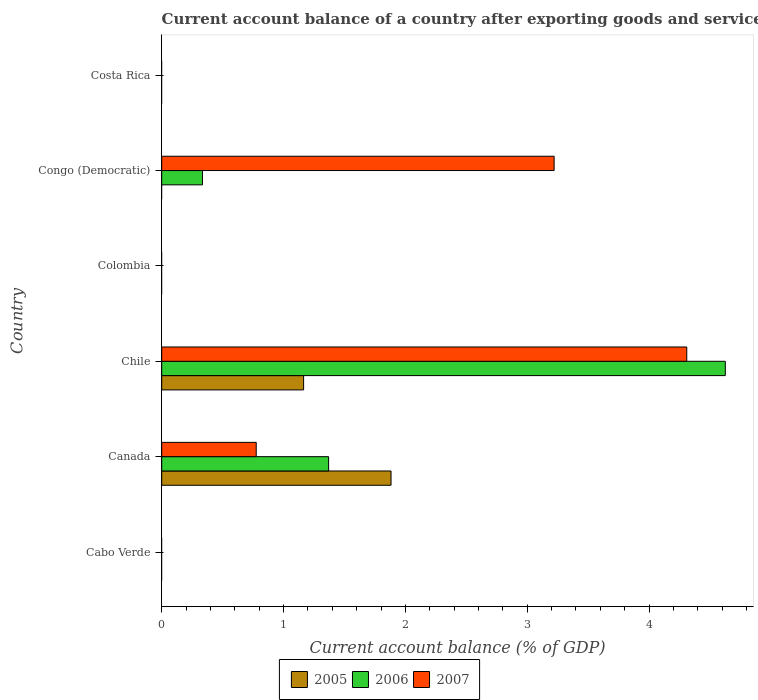How many different coloured bars are there?
Your answer should be very brief. 3. How many bars are there on the 6th tick from the bottom?
Ensure brevity in your answer.  0. What is the label of the 6th group of bars from the top?
Your response must be concise. Cabo Verde. What is the account balance in 2005 in Chile?
Give a very brief answer. 1.16. Across all countries, what is the maximum account balance in 2007?
Offer a terse response. 4.31. In which country was the account balance in 2007 maximum?
Your response must be concise. Chile. What is the total account balance in 2005 in the graph?
Your answer should be very brief. 3.05. What is the difference between the account balance in 2006 in Canada and that in Chile?
Ensure brevity in your answer.  -3.26. What is the difference between the account balance in 2005 in Chile and the account balance in 2006 in Congo (Democratic)?
Keep it short and to the point. 0.83. What is the average account balance in 2006 per country?
Provide a short and direct response. 1.05. What is the difference between the account balance in 2005 and account balance in 2007 in Chile?
Your response must be concise. -3.14. In how many countries, is the account balance in 2005 greater than 1 %?
Provide a succinct answer. 2. Is the account balance in 2007 in Canada less than that in Chile?
Provide a succinct answer. Yes. What is the difference between the highest and the second highest account balance in 2007?
Offer a terse response. 1.09. What is the difference between the highest and the lowest account balance in 2005?
Give a very brief answer. 1.88. How many bars are there?
Your response must be concise. 8. How many countries are there in the graph?
Make the answer very short. 6. What is the difference between two consecutive major ticks on the X-axis?
Keep it short and to the point. 1. Are the values on the major ticks of X-axis written in scientific E-notation?
Your answer should be compact. No. How many legend labels are there?
Keep it short and to the point. 3. How are the legend labels stacked?
Ensure brevity in your answer.  Horizontal. What is the title of the graph?
Keep it short and to the point. Current account balance of a country after exporting goods and services. What is the label or title of the X-axis?
Your answer should be compact. Current account balance (% of GDP). What is the label or title of the Y-axis?
Offer a very short reply. Country. What is the Current account balance (% of GDP) in 2005 in Cabo Verde?
Your answer should be very brief. 0. What is the Current account balance (% of GDP) of 2005 in Canada?
Your response must be concise. 1.88. What is the Current account balance (% of GDP) of 2006 in Canada?
Your answer should be compact. 1.37. What is the Current account balance (% of GDP) in 2007 in Canada?
Give a very brief answer. 0.78. What is the Current account balance (% of GDP) of 2005 in Chile?
Give a very brief answer. 1.16. What is the Current account balance (% of GDP) in 2006 in Chile?
Ensure brevity in your answer.  4.63. What is the Current account balance (% of GDP) in 2007 in Chile?
Provide a succinct answer. 4.31. What is the Current account balance (% of GDP) in 2005 in Colombia?
Offer a very short reply. 0. What is the Current account balance (% of GDP) in 2006 in Colombia?
Your response must be concise. 0. What is the Current account balance (% of GDP) in 2006 in Congo (Democratic)?
Ensure brevity in your answer.  0.33. What is the Current account balance (% of GDP) in 2007 in Congo (Democratic)?
Provide a succinct answer. 3.22. What is the Current account balance (% of GDP) in 2006 in Costa Rica?
Give a very brief answer. 0. What is the Current account balance (% of GDP) in 2007 in Costa Rica?
Ensure brevity in your answer.  0. Across all countries, what is the maximum Current account balance (% of GDP) of 2005?
Your response must be concise. 1.88. Across all countries, what is the maximum Current account balance (% of GDP) in 2006?
Offer a terse response. 4.63. Across all countries, what is the maximum Current account balance (% of GDP) of 2007?
Ensure brevity in your answer.  4.31. Across all countries, what is the minimum Current account balance (% of GDP) of 2007?
Provide a short and direct response. 0. What is the total Current account balance (% of GDP) in 2005 in the graph?
Your response must be concise. 3.05. What is the total Current account balance (% of GDP) in 2006 in the graph?
Make the answer very short. 6.33. What is the total Current account balance (% of GDP) of 2007 in the graph?
Keep it short and to the point. 8.31. What is the difference between the Current account balance (% of GDP) of 2005 in Canada and that in Chile?
Make the answer very short. 0.72. What is the difference between the Current account balance (% of GDP) of 2006 in Canada and that in Chile?
Your answer should be very brief. -3.26. What is the difference between the Current account balance (% of GDP) in 2007 in Canada and that in Chile?
Give a very brief answer. -3.53. What is the difference between the Current account balance (% of GDP) in 2006 in Canada and that in Congo (Democratic)?
Give a very brief answer. 1.04. What is the difference between the Current account balance (% of GDP) in 2007 in Canada and that in Congo (Democratic)?
Give a very brief answer. -2.44. What is the difference between the Current account balance (% of GDP) of 2006 in Chile and that in Congo (Democratic)?
Your answer should be compact. 4.29. What is the difference between the Current account balance (% of GDP) of 2007 in Chile and that in Congo (Democratic)?
Keep it short and to the point. 1.09. What is the difference between the Current account balance (% of GDP) of 2005 in Canada and the Current account balance (% of GDP) of 2006 in Chile?
Keep it short and to the point. -2.74. What is the difference between the Current account balance (% of GDP) of 2005 in Canada and the Current account balance (% of GDP) of 2007 in Chile?
Offer a very short reply. -2.43. What is the difference between the Current account balance (% of GDP) of 2006 in Canada and the Current account balance (% of GDP) of 2007 in Chile?
Your answer should be very brief. -2.94. What is the difference between the Current account balance (% of GDP) of 2005 in Canada and the Current account balance (% of GDP) of 2006 in Congo (Democratic)?
Ensure brevity in your answer.  1.55. What is the difference between the Current account balance (% of GDP) of 2005 in Canada and the Current account balance (% of GDP) of 2007 in Congo (Democratic)?
Ensure brevity in your answer.  -1.34. What is the difference between the Current account balance (% of GDP) in 2006 in Canada and the Current account balance (% of GDP) in 2007 in Congo (Democratic)?
Offer a terse response. -1.85. What is the difference between the Current account balance (% of GDP) of 2005 in Chile and the Current account balance (% of GDP) of 2006 in Congo (Democratic)?
Make the answer very short. 0.83. What is the difference between the Current account balance (% of GDP) of 2005 in Chile and the Current account balance (% of GDP) of 2007 in Congo (Democratic)?
Your answer should be very brief. -2.06. What is the difference between the Current account balance (% of GDP) in 2006 in Chile and the Current account balance (% of GDP) in 2007 in Congo (Democratic)?
Ensure brevity in your answer.  1.41. What is the average Current account balance (% of GDP) in 2005 per country?
Ensure brevity in your answer.  0.51. What is the average Current account balance (% of GDP) in 2006 per country?
Provide a short and direct response. 1.05. What is the average Current account balance (% of GDP) in 2007 per country?
Your answer should be very brief. 1.38. What is the difference between the Current account balance (% of GDP) of 2005 and Current account balance (% of GDP) of 2006 in Canada?
Provide a succinct answer. 0.51. What is the difference between the Current account balance (% of GDP) in 2005 and Current account balance (% of GDP) in 2007 in Canada?
Your response must be concise. 1.11. What is the difference between the Current account balance (% of GDP) of 2006 and Current account balance (% of GDP) of 2007 in Canada?
Your answer should be very brief. 0.59. What is the difference between the Current account balance (% of GDP) in 2005 and Current account balance (% of GDP) in 2006 in Chile?
Offer a terse response. -3.46. What is the difference between the Current account balance (% of GDP) of 2005 and Current account balance (% of GDP) of 2007 in Chile?
Your response must be concise. -3.14. What is the difference between the Current account balance (% of GDP) in 2006 and Current account balance (% of GDP) in 2007 in Chile?
Provide a succinct answer. 0.32. What is the difference between the Current account balance (% of GDP) of 2006 and Current account balance (% of GDP) of 2007 in Congo (Democratic)?
Your answer should be very brief. -2.89. What is the ratio of the Current account balance (% of GDP) of 2005 in Canada to that in Chile?
Ensure brevity in your answer.  1.62. What is the ratio of the Current account balance (% of GDP) of 2006 in Canada to that in Chile?
Offer a terse response. 0.3. What is the ratio of the Current account balance (% of GDP) of 2007 in Canada to that in Chile?
Provide a short and direct response. 0.18. What is the ratio of the Current account balance (% of GDP) of 2006 in Canada to that in Congo (Democratic)?
Keep it short and to the point. 4.1. What is the ratio of the Current account balance (% of GDP) in 2007 in Canada to that in Congo (Democratic)?
Offer a very short reply. 0.24. What is the ratio of the Current account balance (% of GDP) of 2006 in Chile to that in Congo (Democratic)?
Keep it short and to the point. 13.83. What is the ratio of the Current account balance (% of GDP) in 2007 in Chile to that in Congo (Democratic)?
Your answer should be very brief. 1.34. What is the difference between the highest and the second highest Current account balance (% of GDP) of 2006?
Ensure brevity in your answer.  3.26. What is the difference between the highest and the second highest Current account balance (% of GDP) of 2007?
Your answer should be very brief. 1.09. What is the difference between the highest and the lowest Current account balance (% of GDP) in 2005?
Ensure brevity in your answer.  1.88. What is the difference between the highest and the lowest Current account balance (% of GDP) of 2006?
Your response must be concise. 4.63. What is the difference between the highest and the lowest Current account balance (% of GDP) of 2007?
Offer a very short reply. 4.31. 